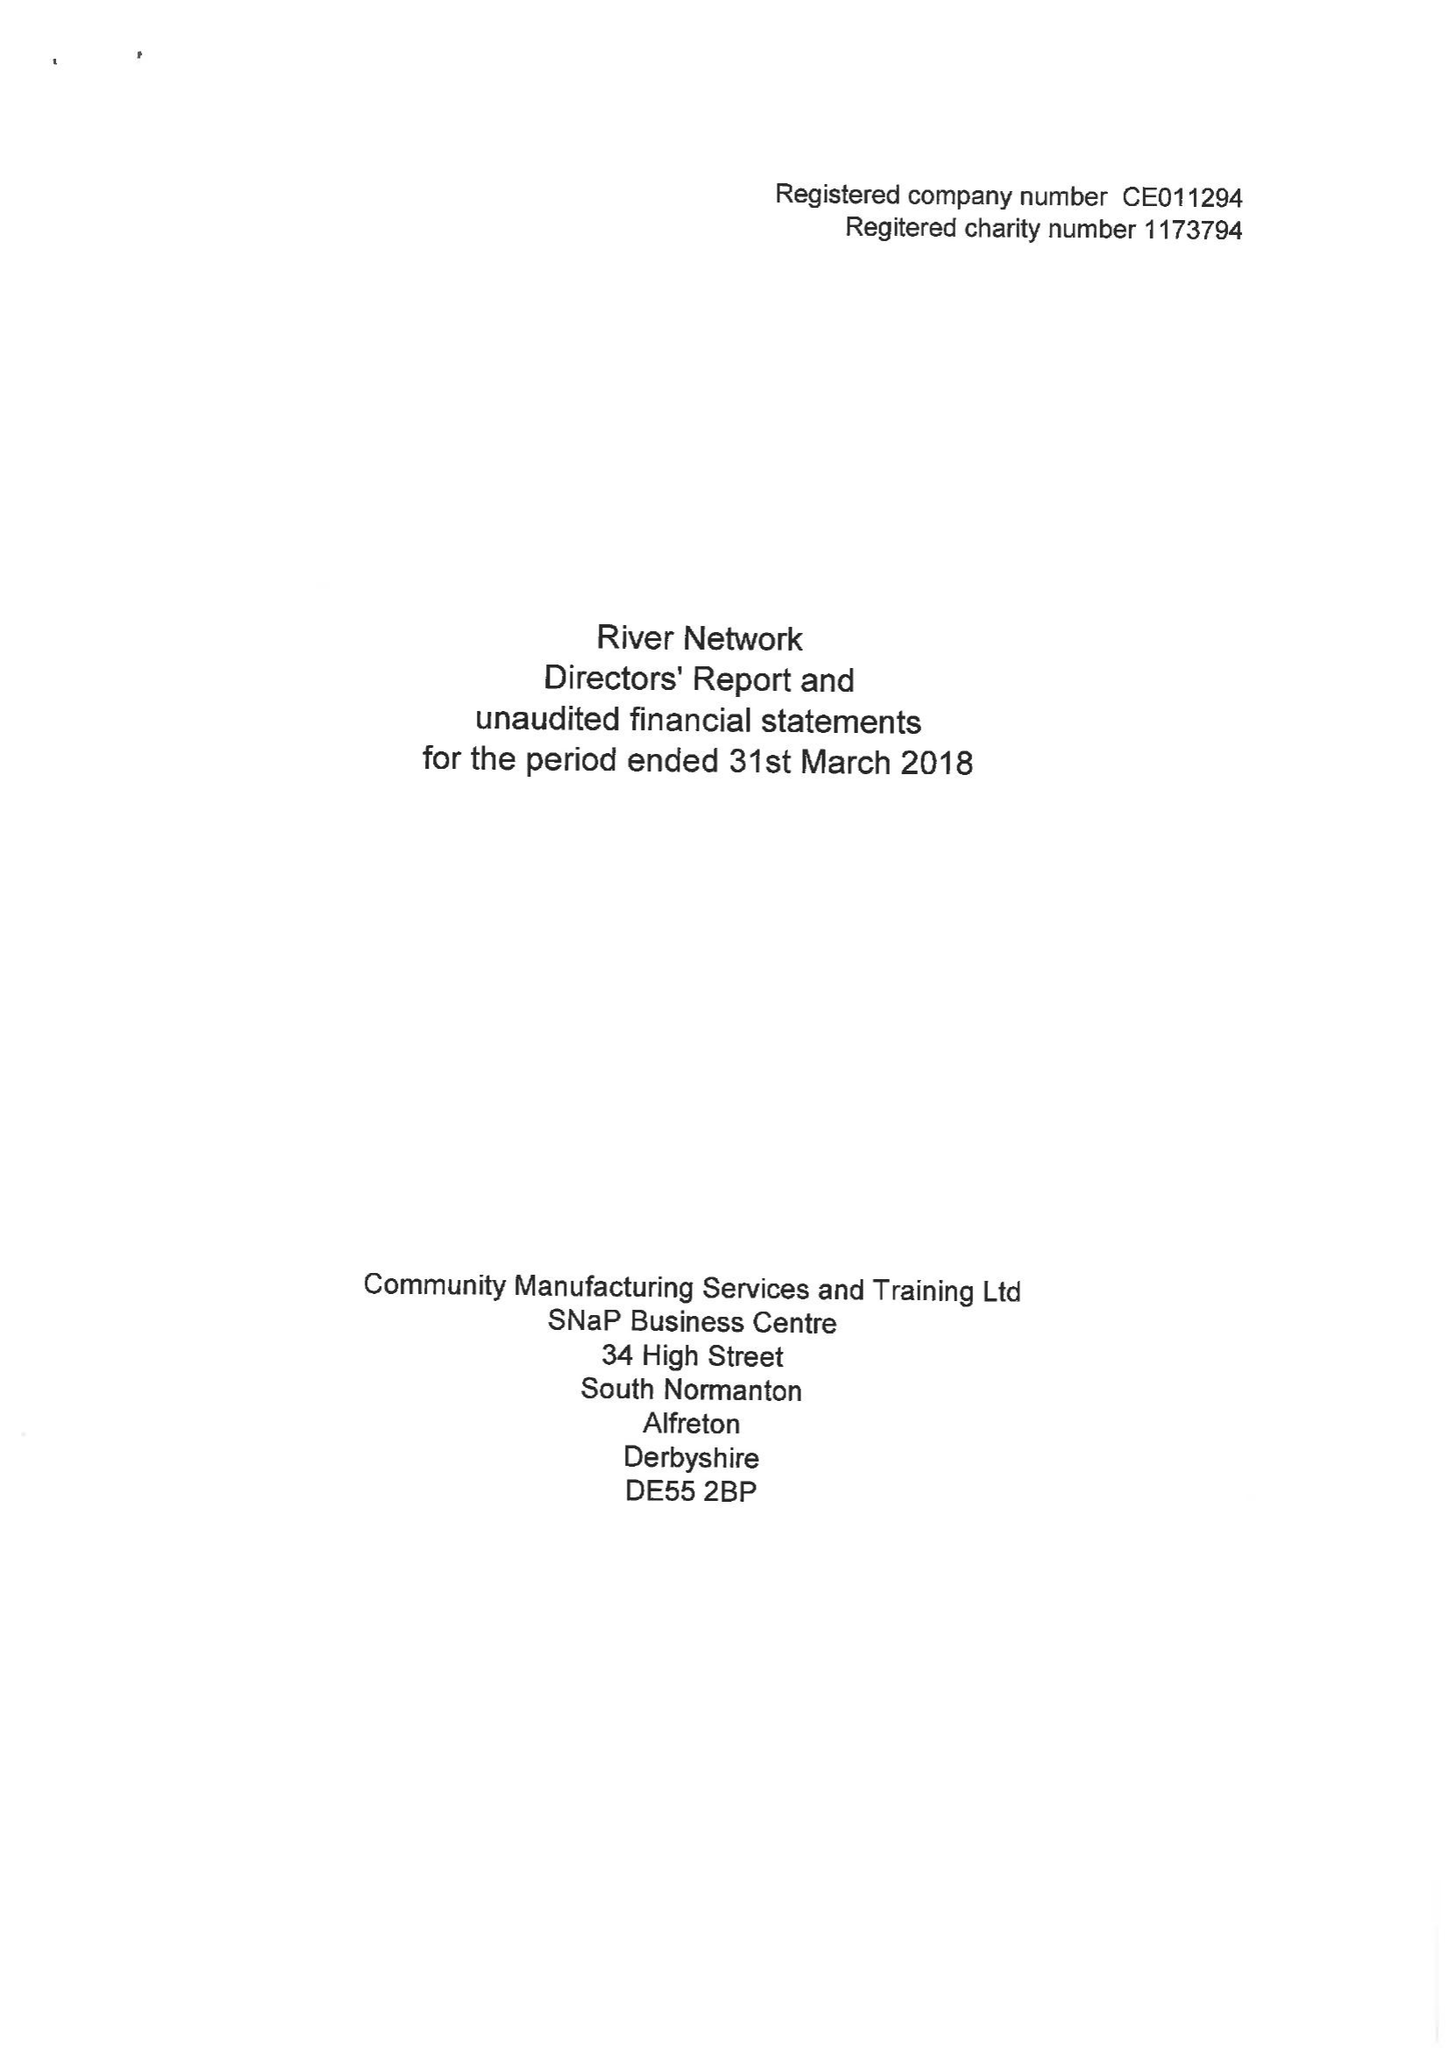What is the value for the address__street_line?
Answer the question using a single word or phrase. None 